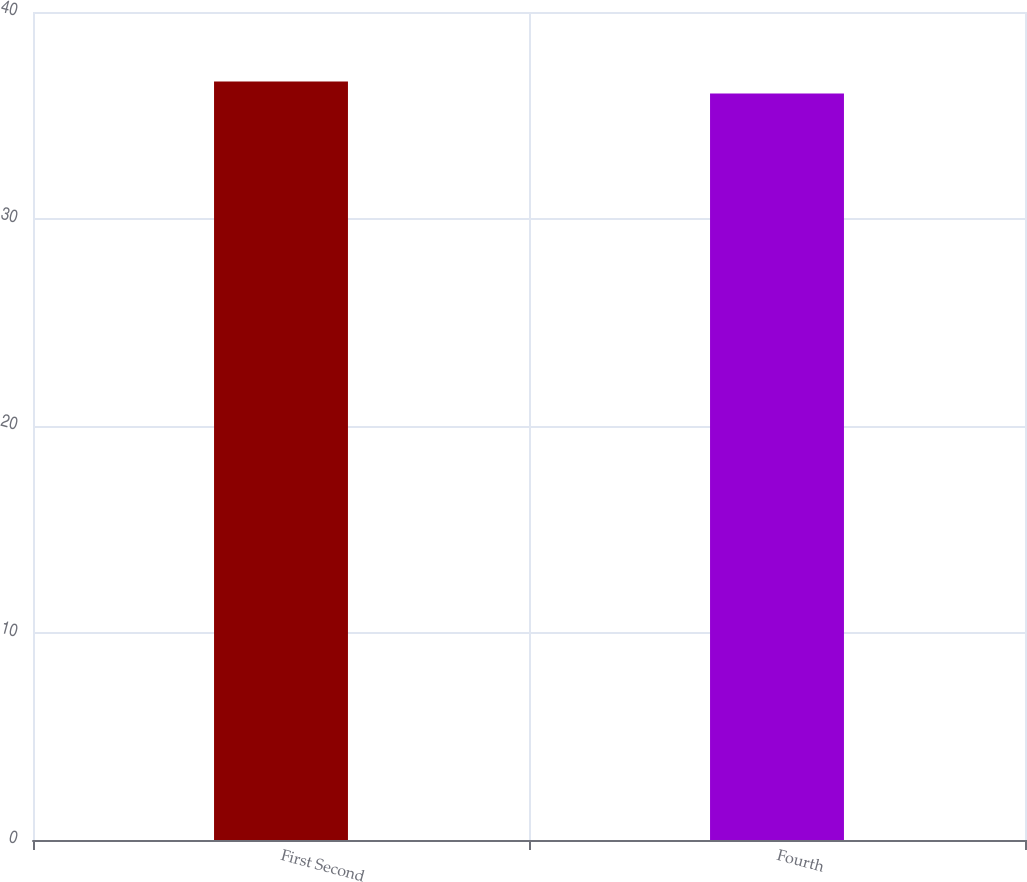<chart> <loc_0><loc_0><loc_500><loc_500><bar_chart><fcel>First Second<fcel>Fourth<nl><fcel>36.64<fcel>36.06<nl></chart> 